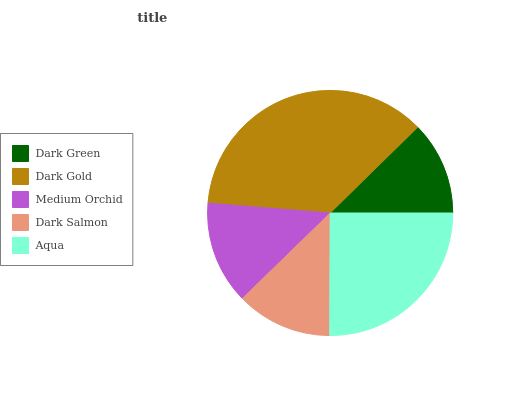Is Dark Green the minimum?
Answer yes or no. Yes. Is Dark Gold the maximum?
Answer yes or no. Yes. Is Medium Orchid the minimum?
Answer yes or no. No. Is Medium Orchid the maximum?
Answer yes or no. No. Is Dark Gold greater than Medium Orchid?
Answer yes or no. Yes. Is Medium Orchid less than Dark Gold?
Answer yes or no. Yes. Is Medium Orchid greater than Dark Gold?
Answer yes or no. No. Is Dark Gold less than Medium Orchid?
Answer yes or no. No. Is Medium Orchid the high median?
Answer yes or no. Yes. Is Medium Orchid the low median?
Answer yes or no. Yes. Is Aqua the high median?
Answer yes or no. No. Is Dark Salmon the low median?
Answer yes or no. No. 